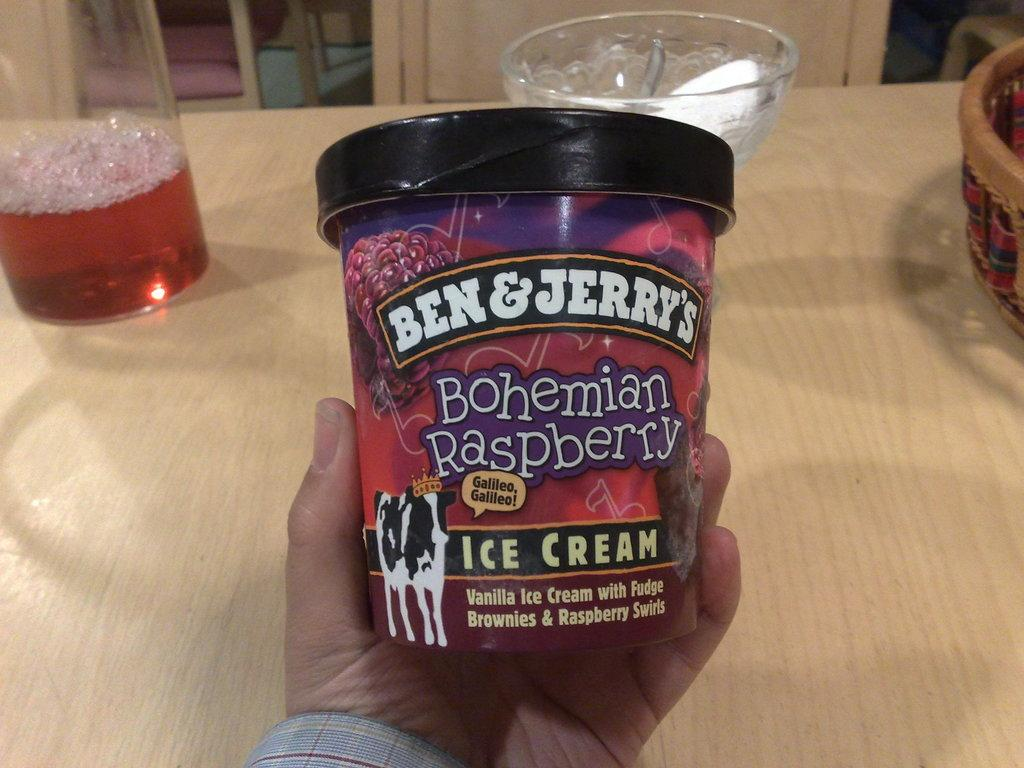What is the person's hand holding in the image? There is a person's hand holding a packed ice cream in the image. What else can be seen on the table in the image? There is a glass of drink, a bowl, and other objects on the table. What might be used for serving or holding food in the image? The bowl can be used for serving or holding food. What type of seating is available in front of the table in the image? There are chairs in front of the table. What type of error can be seen in the image? There is no error present in the image. What type of pear is being traded in the image? There is no pear or trade activity depicted in the image. 